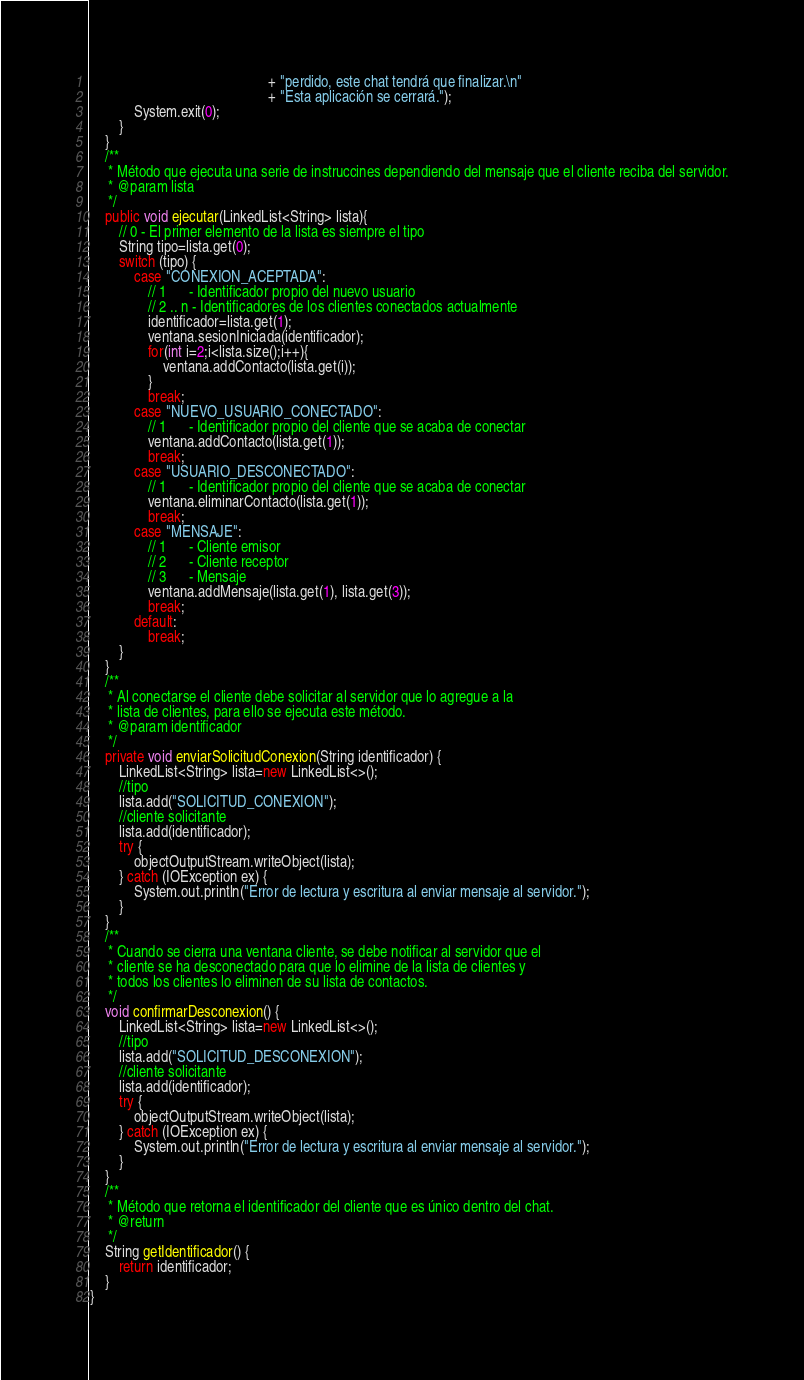Convert code to text. <code><loc_0><loc_0><loc_500><loc_500><_Java_>                                                 + "perdido, este chat tendrá que finalizar.\n"
                                                 + "Esta aplicación se cerrará.");
            System.exit(0);
        }
    }
    /**
     * Método que ejecuta una serie de instruccines dependiendo del mensaje que el cliente reciba del servidor.
     * @param lista
     */
    public void ejecutar(LinkedList<String> lista){
        // 0 - El primer elemento de la lista es siempre el tipo
        String tipo=lista.get(0);
        switch (tipo) {
            case "CONEXION_ACEPTADA":
                // 1      - Identificador propio del nuevo usuario
                // 2 .. n - Identificadores de los clientes conectados actualmente
                identificador=lista.get(1);
                ventana.sesionIniciada(identificador);
                for(int i=2;i<lista.size();i++){
                    ventana.addContacto(lista.get(i));
                }
                break;
            case "NUEVO_USUARIO_CONECTADO":
                // 1      - Identificador propio del cliente que se acaba de conectar
                ventana.addContacto(lista.get(1));
                break;
            case "USUARIO_DESCONECTADO":
                // 1      - Identificador propio del cliente que se acaba de conectar
                ventana.eliminarContacto(lista.get(1));
                break;                
            case "MENSAJE":
                // 1      - Cliente emisor
                // 2      - Cliente receptor
                // 3      - Mensaje
                ventana.addMensaje(lista.get(1), lista.get(3));
                break;
            default:
                break;
        }
    }
    /**
     * Al conectarse el cliente debe solicitar al servidor que lo agregue a la 
     * lista de clientes, para ello se ejecuta este método.
     * @param identificador 
     */
    private void enviarSolicitudConexion(String identificador) {
        LinkedList<String> lista=new LinkedList<>();
        //tipo
        lista.add("SOLICITUD_CONEXION");
        //cliente solicitante
        lista.add(identificador);
        try {
            objectOutputStream.writeObject(lista);
        } catch (IOException ex) {
            System.out.println("Error de lectura y escritura al enviar mensaje al servidor.");
        }
    }
    /**
     * Cuando se cierra una ventana cliente, se debe notificar al servidor que el 
     * cliente se ha desconectado para que lo elimine de la lista de clientes y 
     * todos los clientes lo eliminen de su lista de contactos.
     */
    void confirmarDesconexion() {
        LinkedList<String> lista=new LinkedList<>();
        //tipo
        lista.add("SOLICITUD_DESCONEXION");
        //cliente solicitante
        lista.add(identificador);
        try {
            objectOutputStream.writeObject(lista);
        } catch (IOException ex) {
            System.out.println("Error de lectura y escritura al enviar mensaje al servidor.");
        }
    }
    /**
     * Método que retorna el identificador del cliente que es único dentro del chat.
     * @return 
     */
    String getIdentificador() {
        return identificador;
    }
}
</code> 